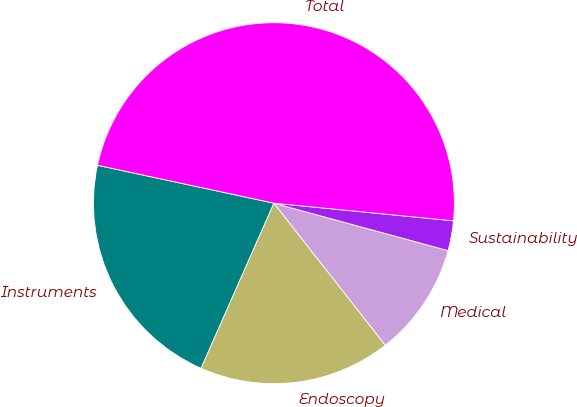Convert chart. <chart><loc_0><loc_0><loc_500><loc_500><pie_chart><fcel>Instruments<fcel>Endoscopy<fcel>Medical<fcel>Sustainability<fcel>Total<nl><fcel>21.75%<fcel>17.2%<fcel>10.18%<fcel>2.67%<fcel>48.19%<nl></chart> 